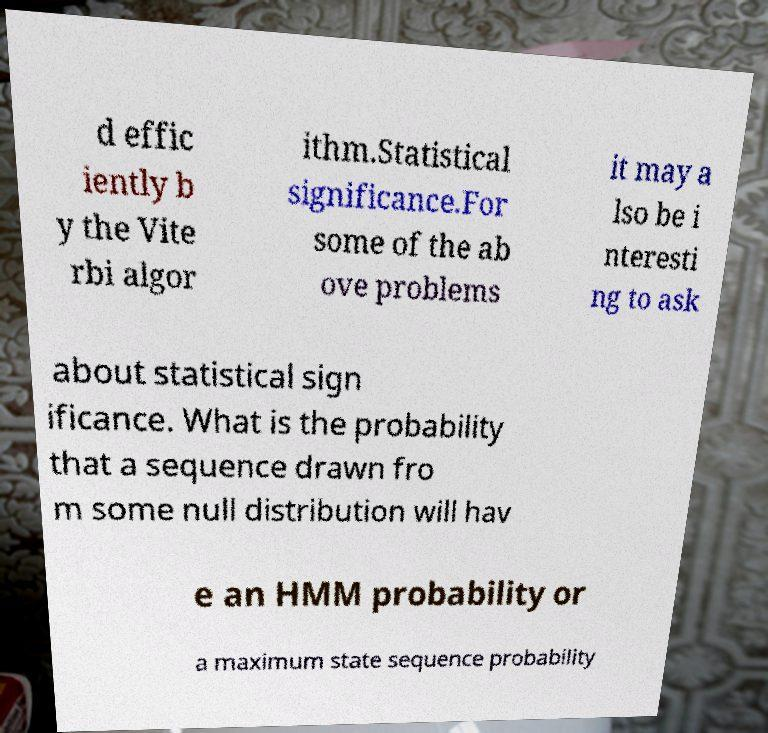What messages or text are displayed in this image? I need them in a readable, typed format. d effic iently b y the Vite rbi algor ithm.Statistical significance.For some of the ab ove problems it may a lso be i nteresti ng to ask about statistical sign ificance. What is the probability that a sequence drawn fro m some null distribution will hav e an HMM probability or a maximum state sequence probability 